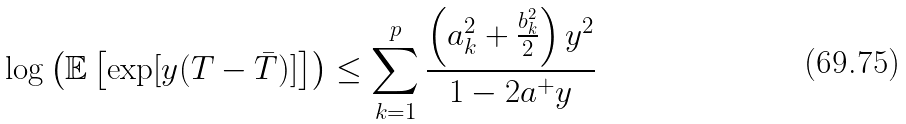Convert formula to latex. <formula><loc_0><loc_0><loc_500><loc_500>\log \left ( \mathbb { E } \left [ \exp [ y ( T - \bar { T } ) ] \right ] \right ) \leq \sum _ { k = 1 } ^ { p } \frac { \left ( a _ { k } ^ { 2 } + \frac { b _ { k } ^ { 2 } } { 2 } \right ) y ^ { 2 } } { 1 - 2 a ^ { + } y }</formula> 